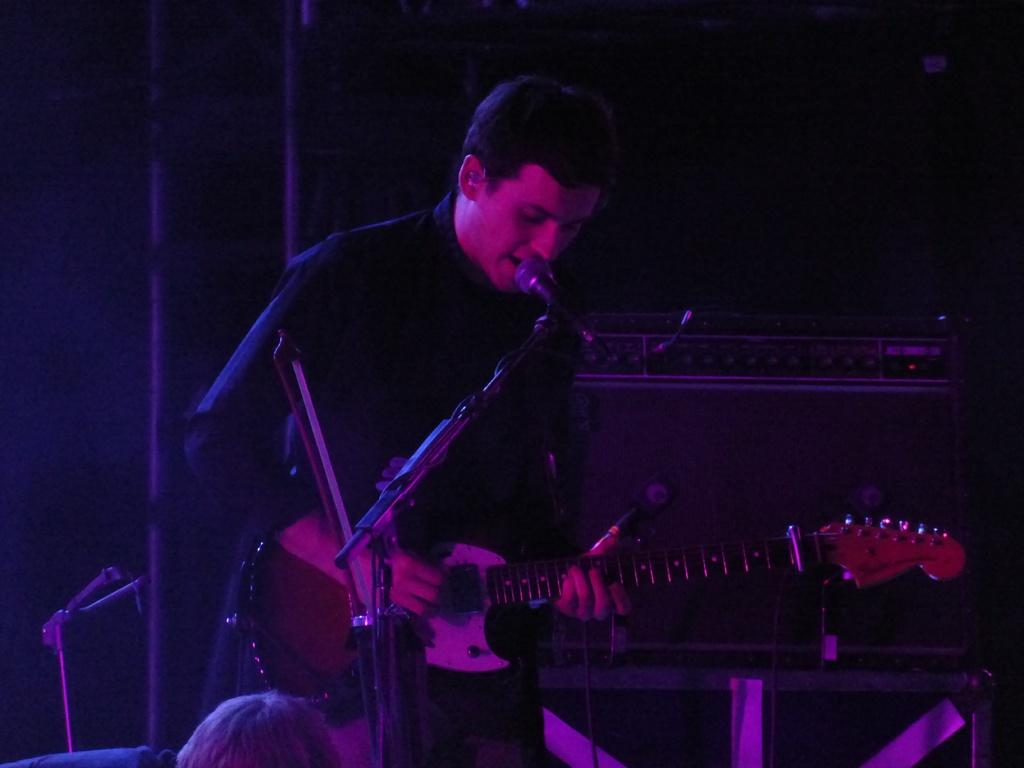What is the man in the image doing? The man is playing a guitar and singing. What instrument is the man using in the image? The man is playing a guitar. What device is present for amplifying the man's voice? There is a microphone in the image. How is the microphone positioned in the image? The microphone has a holder in the image. How many bears are visible in the image? There are no bears present in the image. What type of act is the man performing in the image? The image does not specify the type of act the man is performing; it only shows him playing a guitar and singing. 